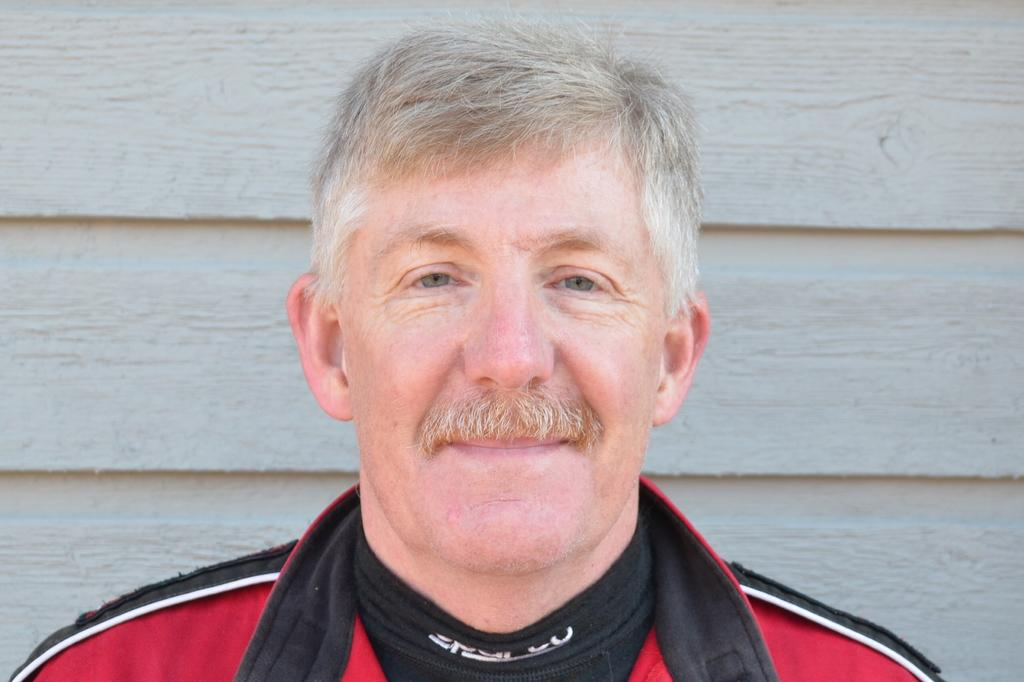Who or what is present in the image? There is a person in the image. What is the person wearing? The person is wearing a dress. What can be seen in the background of the image? There is a wall in the background of the image. What arithmetic problem is the person solving in the image? There is no arithmetic problem visible in the image. What type of vessel is the person holding in the image? There is no vessel present in the image. 